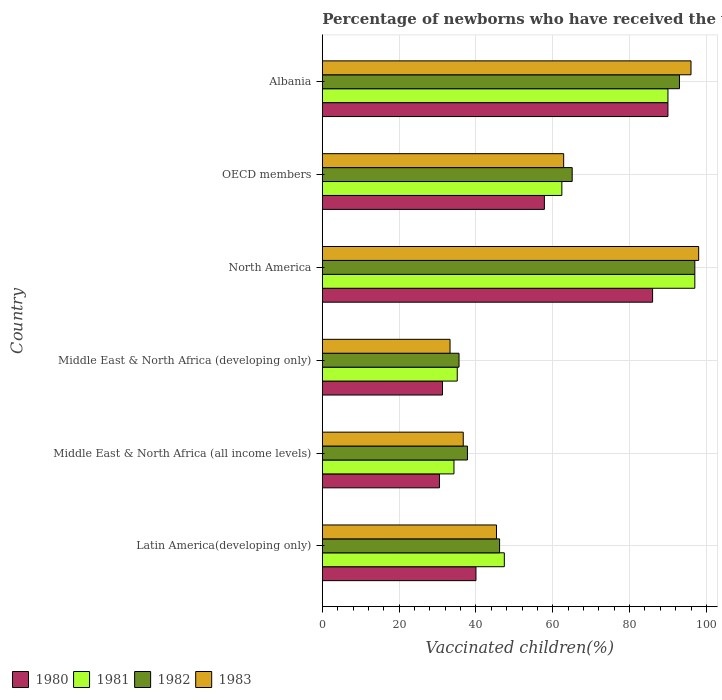How many different coloured bars are there?
Give a very brief answer. 4. Are the number of bars per tick equal to the number of legend labels?
Make the answer very short. Yes. How many bars are there on the 6th tick from the top?
Make the answer very short. 4. How many bars are there on the 4th tick from the bottom?
Your response must be concise. 4. What is the label of the 4th group of bars from the top?
Ensure brevity in your answer.  Middle East & North Africa (developing only). What is the percentage of vaccinated children in 1983 in Middle East & North Africa (all income levels)?
Your answer should be very brief. 36.7. Across all countries, what is the maximum percentage of vaccinated children in 1981?
Ensure brevity in your answer.  97. Across all countries, what is the minimum percentage of vaccinated children in 1981?
Ensure brevity in your answer.  34.28. In which country was the percentage of vaccinated children in 1982 minimum?
Ensure brevity in your answer.  Middle East & North Africa (developing only). What is the total percentage of vaccinated children in 1980 in the graph?
Your response must be concise. 335.62. What is the difference between the percentage of vaccinated children in 1980 in Middle East & North Africa (developing only) and that in North America?
Your response must be concise. -54.71. What is the difference between the percentage of vaccinated children in 1982 in OECD members and the percentage of vaccinated children in 1980 in North America?
Your response must be concise. -20.94. What is the average percentage of vaccinated children in 1982 per country?
Provide a short and direct response. 62.43. What is the difference between the percentage of vaccinated children in 1983 and percentage of vaccinated children in 1982 in Latin America(developing only)?
Provide a short and direct response. -0.8. In how many countries, is the percentage of vaccinated children in 1982 greater than 48 %?
Your answer should be very brief. 3. What is the ratio of the percentage of vaccinated children in 1983 in Latin America(developing only) to that in OECD members?
Your response must be concise. 0.72. What is the difference between the highest and the lowest percentage of vaccinated children in 1981?
Provide a succinct answer. 62.72. Is the sum of the percentage of vaccinated children in 1982 in Albania and OECD members greater than the maximum percentage of vaccinated children in 1980 across all countries?
Your answer should be very brief. Yes. Is it the case that in every country, the sum of the percentage of vaccinated children in 1980 and percentage of vaccinated children in 1981 is greater than the sum of percentage of vaccinated children in 1982 and percentage of vaccinated children in 1983?
Your answer should be very brief. No. What does the 2nd bar from the top in Latin America(developing only) represents?
Your answer should be compact. 1982. What does the 4th bar from the bottom in Middle East & North Africa (all income levels) represents?
Your answer should be very brief. 1983. Is it the case that in every country, the sum of the percentage of vaccinated children in 1982 and percentage of vaccinated children in 1981 is greater than the percentage of vaccinated children in 1983?
Give a very brief answer. Yes. What is the difference between two consecutive major ticks on the X-axis?
Offer a terse response. 20. Are the values on the major ticks of X-axis written in scientific E-notation?
Give a very brief answer. No. Does the graph contain any zero values?
Ensure brevity in your answer.  No. Does the graph contain grids?
Offer a very short reply. Yes. How many legend labels are there?
Offer a very short reply. 4. What is the title of the graph?
Give a very brief answer. Percentage of newborns who have received the vaccination for measles. What is the label or title of the X-axis?
Keep it short and to the point. Vaccinated children(%). What is the Vaccinated children(%) of 1980 in Latin America(developing only)?
Keep it short and to the point. 40.01. What is the Vaccinated children(%) in 1981 in Latin America(developing only)?
Your answer should be compact. 47.39. What is the Vaccinated children(%) in 1982 in Latin America(developing only)?
Provide a succinct answer. 46.16. What is the Vaccinated children(%) in 1983 in Latin America(developing only)?
Your answer should be very brief. 45.35. What is the Vaccinated children(%) in 1980 in Middle East & North Africa (all income levels)?
Provide a short and direct response. 30.5. What is the Vaccinated children(%) in 1981 in Middle East & North Africa (all income levels)?
Your answer should be very brief. 34.28. What is the Vaccinated children(%) in 1982 in Middle East & North Africa (all income levels)?
Your response must be concise. 37.79. What is the Vaccinated children(%) of 1983 in Middle East & North Africa (all income levels)?
Your response must be concise. 36.7. What is the Vaccinated children(%) in 1980 in Middle East & North Africa (developing only)?
Give a very brief answer. 31.29. What is the Vaccinated children(%) of 1981 in Middle East & North Africa (developing only)?
Offer a terse response. 35.13. What is the Vaccinated children(%) of 1982 in Middle East & North Africa (developing only)?
Give a very brief answer. 35.6. What is the Vaccinated children(%) in 1983 in Middle East & North Africa (developing only)?
Your answer should be compact. 33.26. What is the Vaccinated children(%) in 1980 in North America?
Offer a very short reply. 86. What is the Vaccinated children(%) in 1981 in North America?
Provide a succinct answer. 97. What is the Vaccinated children(%) in 1982 in North America?
Offer a very short reply. 97. What is the Vaccinated children(%) of 1983 in North America?
Your response must be concise. 98. What is the Vaccinated children(%) in 1980 in OECD members?
Keep it short and to the point. 57.82. What is the Vaccinated children(%) of 1981 in OECD members?
Ensure brevity in your answer.  62.37. What is the Vaccinated children(%) of 1982 in OECD members?
Offer a very short reply. 65.06. What is the Vaccinated children(%) in 1983 in OECD members?
Keep it short and to the point. 62.84. What is the Vaccinated children(%) of 1980 in Albania?
Make the answer very short. 90. What is the Vaccinated children(%) of 1981 in Albania?
Offer a very short reply. 90. What is the Vaccinated children(%) of 1982 in Albania?
Give a very brief answer. 93. What is the Vaccinated children(%) in 1983 in Albania?
Your answer should be compact. 96. Across all countries, what is the maximum Vaccinated children(%) in 1980?
Offer a very short reply. 90. Across all countries, what is the maximum Vaccinated children(%) in 1981?
Your response must be concise. 97. Across all countries, what is the maximum Vaccinated children(%) in 1982?
Offer a very short reply. 97. Across all countries, what is the maximum Vaccinated children(%) in 1983?
Your answer should be compact. 98. Across all countries, what is the minimum Vaccinated children(%) in 1980?
Your answer should be very brief. 30.5. Across all countries, what is the minimum Vaccinated children(%) in 1981?
Ensure brevity in your answer.  34.28. Across all countries, what is the minimum Vaccinated children(%) of 1982?
Provide a short and direct response. 35.6. Across all countries, what is the minimum Vaccinated children(%) in 1983?
Your answer should be compact. 33.26. What is the total Vaccinated children(%) in 1980 in the graph?
Your answer should be compact. 335.62. What is the total Vaccinated children(%) in 1981 in the graph?
Your answer should be very brief. 366.18. What is the total Vaccinated children(%) of 1982 in the graph?
Ensure brevity in your answer.  374.61. What is the total Vaccinated children(%) in 1983 in the graph?
Your answer should be compact. 372.15. What is the difference between the Vaccinated children(%) in 1980 in Latin America(developing only) and that in Middle East & North Africa (all income levels)?
Offer a very short reply. 9.51. What is the difference between the Vaccinated children(%) of 1981 in Latin America(developing only) and that in Middle East & North Africa (all income levels)?
Offer a very short reply. 13.11. What is the difference between the Vaccinated children(%) of 1982 in Latin America(developing only) and that in Middle East & North Africa (all income levels)?
Your answer should be very brief. 8.36. What is the difference between the Vaccinated children(%) in 1983 in Latin America(developing only) and that in Middle East & North Africa (all income levels)?
Your response must be concise. 8.66. What is the difference between the Vaccinated children(%) of 1980 in Latin America(developing only) and that in Middle East & North Africa (developing only)?
Ensure brevity in your answer.  8.72. What is the difference between the Vaccinated children(%) of 1981 in Latin America(developing only) and that in Middle East & North Africa (developing only)?
Ensure brevity in your answer.  12.26. What is the difference between the Vaccinated children(%) in 1982 in Latin America(developing only) and that in Middle East & North Africa (developing only)?
Your answer should be compact. 10.56. What is the difference between the Vaccinated children(%) in 1983 in Latin America(developing only) and that in Middle East & North Africa (developing only)?
Your answer should be compact. 12.1. What is the difference between the Vaccinated children(%) in 1980 in Latin America(developing only) and that in North America?
Make the answer very short. -45.99. What is the difference between the Vaccinated children(%) in 1981 in Latin America(developing only) and that in North America?
Provide a short and direct response. -49.61. What is the difference between the Vaccinated children(%) of 1982 in Latin America(developing only) and that in North America?
Provide a short and direct response. -50.84. What is the difference between the Vaccinated children(%) in 1983 in Latin America(developing only) and that in North America?
Provide a succinct answer. -52.65. What is the difference between the Vaccinated children(%) in 1980 in Latin America(developing only) and that in OECD members?
Your answer should be compact. -17.82. What is the difference between the Vaccinated children(%) in 1981 in Latin America(developing only) and that in OECD members?
Offer a terse response. -14.98. What is the difference between the Vaccinated children(%) in 1982 in Latin America(developing only) and that in OECD members?
Your answer should be very brief. -18.91. What is the difference between the Vaccinated children(%) of 1983 in Latin America(developing only) and that in OECD members?
Ensure brevity in your answer.  -17.49. What is the difference between the Vaccinated children(%) in 1980 in Latin America(developing only) and that in Albania?
Ensure brevity in your answer.  -49.99. What is the difference between the Vaccinated children(%) of 1981 in Latin America(developing only) and that in Albania?
Offer a very short reply. -42.61. What is the difference between the Vaccinated children(%) of 1982 in Latin America(developing only) and that in Albania?
Keep it short and to the point. -46.84. What is the difference between the Vaccinated children(%) in 1983 in Latin America(developing only) and that in Albania?
Your answer should be very brief. -50.65. What is the difference between the Vaccinated children(%) of 1980 in Middle East & North Africa (all income levels) and that in Middle East & North Africa (developing only)?
Your answer should be compact. -0.79. What is the difference between the Vaccinated children(%) in 1981 in Middle East & North Africa (all income levels) and that in Middle East & North Africa (developing only)?
Your answer should be compact. -0.86. What is the difference between the Vaccinated children(%) in 1982 in Middle East & North Africa (all income levels) and that in Middle East & North Africa (developing only)?
Offer a very short reply. 2.19. What is the difference between the Vaccinated children(%) in 1983 in Middle East & North Africa (all income levels) and that in Middle East & North Africa (developing only)?
Give a very brief answer. 3.44. What is the difference between the Vaccinated children(%) of 1980 in Middle East & North Africa (all income levels) and that in North America?
Give a very brief answer. -55.5. What is the difference between the Vaccinated children(%) of 1981 in Middle East & North Africa (all income levels) and that in North America?
Offer a very short reply. -62.72. What is the difference between the Vaccinated children(%) of 1982 in Middle East & North Africa (all income levels) and that in North America?
Provide a succinct answer. -59.21. What is the difference between the Vaccinated children(%) of 1983 in Middle East & North Africa (all income levels) and that in North America?
Make the answer very short. -61.3. What is the difference between the Vaccinated children(%) of 1980 in Middle East & North Africa (all income levels) and that in OECD members?
Your answer should be very brief. -27.32. What is the difference between the Vaccinated children(%) of 1981 in Middle East & North Africa (all income levels) and that in OECD members?
Provide a succinct answer. -28.1. What is the difference between the Vaccinated children(%) of 1982 in Middle East & North Africa (all income levels) and that in OECD members?
Your answer should be very brief. -27.27. What is the difference between the Vaccinated children(%) in 1983 in Middle East & North Africa (all income levels) and that in OECD members?
Provide a short and direct response. -26.15. What is the difference between the Vaccinated children(%) of 1980 in Middle East & North Africa (all income levels) and that in Albania?
Your answer should be compact. -59.5. What is the difference between the Vaccinated children(%) in 1981 in Middle East & North Africa (all income levels) and that in Albania?
Provide a succinct answer. -55.72. What is the difference between the Vaccinated children(%) of 1982 in Middle East & North Africa (all income levels) and that in Albania?
Your response must be concise. -55.21. What is the difference between the Vaccinated children(%) in 1983 in Middle East & North Africa (all income levels) and that in Albania?
Give a very brief answer. -59.3. What is the difference between the Vaccinated children(%) of 1980 in Middle East & North Africa (developing only) and that in North America?
Your answer should be very brief. -54.71. What is the difference between the Vaccinated children(%) of 1981 in Middle East & North Africa (developing only) and that in North America?
Your answer should be very brief. -61.87. What is the difference between the Vaccinated children(%) in 1982 in Middle East & North Africa (developing only) and that in North America?
Give a very brief answer. -61.4. What is the difference between the Vaccinated children(%) in 1983 in Middle East & North Africa (developing only) and that in North America?
Make the answer very short. -64.74. What is the difference between the Vaccinated children(%) in 1980 in Middle East & North Africa (developing only) and that in OECD members?
Ensure brevity in your answer.  -26.53. What is the difference between the Vaccinated children(%) in 1981 in Middle East & North Africa (developing only) and that in OECD members?
Your answer should be very brief. -27.24. What is the difference between the Vaccinated children(%) of 1982 in Middle East & North Africa (developing only) and that in OECD members?
Your answer should be very brief. -29.46. What is the difference between the Vaccinated children(%) in 1983 in Middle East & North Africa (developing only) and that in OECD members?
Give a very brief answer. -29.59. What is the difference between the Vaccinated children(%) in 1980 in Middle East & North Africa (developing only) and that in Albania?
Your answer should be very brief. -58.71. What is the difference between the Vaccinated children(%) of 1981 in Middle East & North Africa (developing only) and that in Albania?
Your answer should be very brief. -54.87. What is the difference between the Vaccinated children(%) in 1982 in Middle East & North Africa (developing only) and that in Albania?
Your response must be concise. -57.4. What is the difference between the Vaccinated children(%) of 1983 in Middle East & North Africa (developing only) and that in Albania?
Give a very brief answer. -62.74. What is the difference between the Vaccinated children(%) in 1980 in North America and that in OECD members?
Your response must be concise. 28.18. What is the difference between the Vaccinated children(%) in 1981 in North America and that in OECD members?
Offer a terse response. 34.63. What is the difference between the Vaccinated children(%) of 1982 in North America and that in OECD members?
Provide a succinct answer. 31.94. What is the difference between the Vaccinated children(%) of 1983 in North America and that in OECD members?
Give a very brief answer. 35.16. What is the difference between the Vaccinated children(%) in 1980 in North America and that in Albania?
Make the answer very short. -4. What is the difference between the Vaccinated children(%) in 1981 in North America and that in Albania?
Keep it short and to the point. 7. What is the difference between the Vaccinated children(%) in 1982 in North America and that in Albania?
Your response must be concise. 4. What is the difference between the Vaccinated children(%) in 1983 in North America and that in Albania?
Ensure brevity in your answer.  2. What is the difference between the Vaccinated children(%) in 1980 in OECD members and that in Albania?
Keep it short and to the point. -32.18. What is the difference between the Vaccinated children(%) of 1981 in OECD members and that in Albania?
Your answer should be very brief. -27.63. What is the difference between the Vaccinated children(%) of 1982 in OECD members and that in Albania?
Offer a very short reply. -27.94. What is the difference between the Vaccinated children(%) of 1983 in OECD members and that in Albania?
Your response must be concise. -33.16. What is the difference between the Vaccinated children(%) in 1980 in Latin America(developing only) and the Vaccinated children(%) in 1981 in Middle East & North Africa (all income levels)?
Provide a succinct answer. 5.73. What is the difference between the Vaccinated children(%) of 1980 in Latin America(developing only) and the Vaccinated children(%) of 1982 in Middle East & North Africa (all income levels)?
Your answer should be compact. 2.22. What is the difference between the Vaccinated children(%) of 1980 in Latin America(developing only) and the Vaccinated children(%) of 1983 in Middle East & North Africa (all income levels)?
Your response must be concise. 3.31. What is the difference between the Vaccinated children(%) of 1981 in Latin America(developing only) and the Vaccinated children(%) of 1982 in Middle East & North Africa (all income levels)?
Make the answer very short. 9.6. What is the difference between the Vaccinated children(%) of 1981 in Latin America(developing only) and the Vaccinated children(%) of 1983 in Middle East & North Africa (all income levels)?
Your answer should be very brief. 10.7. What is the difference between the Vaccinated children(%) of 1982 in Latin America(developing only) and the Vaccinated children(%) of 1983 in Middle East & North Africa (all income levels)?
Make the answer very short. 9.46. What is the difference between the Vaccinated children(%) of 1980 in Latin America(developing only) and the Vaccinated children(%) of 1981 in Middle East & North Africa (developing only)?
Give a very brief answer. 4.87. What is the difference between the Vaccinated children(%) of 1980 in Latin America(developing only) and the Vaccinated children(%) of 1982 in Middle East & North Africa (developing only)?
Give a very brief answer. 4.41. What is the difference between the Vaccinated children(%) of 1980 in Latin America(developing only) and the Vaccinated children(%) of 1983 in Middle East & North Africa (developing only)?
Offer a terse response. 6.75. What is the difference between the Vaccinated children(%) of 1981 in Latin America(developing only) and the Vaccinated children(%) of 1982 in Middle East & North Africa (developing only)?
Ensure brevity in your answer.  11.8. What is the difference between the Vaccinated children(%) of 1981 in Latin America(developing only) and the Vaccinated children(%) of 1983 in Middle East & North Africa (developing only)?
Make the answer very short. 14.14. What is the difference between the Vaccinated children(%) of 1982 in Latin America(developing only) and the Vaccinated children(%) of 1983 in Middle East & North Africa (developing only)?
Provide a short and direct response. 12.9. What is the difference between the Vaccinated children(%) of 1980 in Latin America(developing only) and the Vaccinated children(%) of 1981 in North America?
Make the answer very short. -56.99. What is the difference between the Vaccinated children(%) of 1980 in Latin America(developing only) and the Vaccinated children(%) of 1982 in North America?
Offer a terse response. -56.99. What is the difference between the Vaccinated children(%) of 1980 in Latin America(developing only) and the Vaccinated children(%) of 1983 in North America?
Keep it short and to the point. -57.99. What is the difference between the Vaccinated children(%) in 1981 in Latin America(developing only) and the Vaccinated children(%) in 1982 in North America?
Ensure brevity in your answer.  -49.61. What is the difference between the Vaccinated children(%) of 1981 in Latin America(developing only) and the Vaccinated children(%) of 1983 in North America?
Offer a terse response. -50.61. What is the difference between the Vaccinated children(%) in 1982 in Latin America(developing only) and the Vaccinated children(%) in 1983 in North America?
Your answer should be compact. -51.84. What is the difference between the Vaccinated children(%) in 1980 in Latin America(developing only) and the Vaccinated children(%) in 1981 in OECD members?
Provide a succinct answer. -22.37. What is the difference between the Vaccinated children(%) of 1980 in Latin America(developing only) and the Vaccinated children(%) of 1982 in OECD members?
Your response must be concise. -25.05. What is the difference between the Vaccinated children(%) in 1980 in Latin America(developing only) and the Vaccinated children(%) in 1983 in OECD members?
Give a very brief answer. -22.84. What is the difference between the Vaccinated children(%) of 1981 in Latin America(developing only) and the Vaccinated children(%) of 1982 in OECD members?
Offer a terse response. -17.67. What is the difference between the Vaccinated children(%) in 1981 in Latin America(developing only) and the Vaccinated children(%) in 1983 in OECD members?
Make the answer very short. -15.45. What is the difference between the Vaccinated children(%) in 1982 in Latin America(developing only) and the Vaccinated children(%) in 1983 in OECD members?
Your response must be concise. -16.69. What is the difference between the Vaccinated children(%) in 1980 in Latin America(developing only) and the Vaccinated children(%) in 1981 in Albania?
Make the answer very short. -49.99. What is the difference between the Vaccinated children(%) of 1980 in Latin America(developing only) and the Vaccinated children(%) of 1982 in Albania?
Your response must be concise. -52.99. What is the difference between the Vaccinated children(%) of 1980 in Latin America(developing only) and the Vaccinated children(%) of 1983 in Albania?
Your response must be concise. -55.99. What is the difference between the Vaccinated children(%) of 1981 in Latin America(developing only) and the Vaccinated children(%) of 1982 in Albania?
Your response must be concise. -45.61. What is the difference between the Vaccinated children(%) in 1981 in Latin America(developing only) and the Vaccinated children(%) in 1983 in Albania?
Your answer should be very brief. -48.61. What is the difference between the Vaccinated children(%) in 1982 in Latin America(developing only) and the Vaccinated children(%) in 1983 in Albania?
Offer a very short reply. -49.84. What is the difference between the Vaccinated children(%) in 1980 in Middle East & North Africa (all income levels) and the Vaccinated children(%) in 1981 in Middle East & North Africa (developing only)?
Your answer should be compact. -4.63. What is the difference between the Vaccinated children(%) in 1980 in Middle East & North Africa (all income levels) and the Vaccinated children(%) in 1982 in Middle East & North Africa (developing only)?
Give a very brief answer. -5.1. What is the difference between the Vaccinated children(%) of 1980 in Middle East & North Africa (all income levels) and the Vaccinated children(%) of 1983 in Middle East & North Africa (developing only)?
Your answer should be compact. -2.75. What is the difference between the Vaccinated children(%) in 1981 in Middle East & North Africa (all income levels) and the Vaccinated children(%) in 1982 in Middle East & North Africa (developing only)?
Offer a terse response. -1.32. What is the difference between the Vaccinated children(%) in 1981 in Middle East & North Africa (all income levels) and the Vaccinated children(%) in 1983 in Middle East & North Africa (developing only)?
Offer a very short reply. 1.02. What is the difference between the Vaccinated children(%) in 1982 in Middle East & North Africa (all income levels) and the Vaccinated children(%) in 1983 in Middle East & North Africa (developing only)?
Ensure brevity in your answer.  4.54. What is the difference between the Vaccinated children(%) of 1980 in Middle East & North Africa (all income levels) and the Vaccinated children(%) of 1981 in North America?
Keep it short and to the point. -66.5. What is the difference between the Vaccinated children(%) of 1980 in Middle East & North Africa (all income levels) and the Vaccinated children(%) of 1982 in North America?
Ensure brevity in your answer.  -66.5. What is the difference between the Vaccinated children(%) in 1980 in Middle East & North Africa (all income levels) and the Vaccinated children(%) in 1983 in North America?
Your response must be concise. -67.5. What is the difference between the Vaccinated children(%) of 1981 in Middle East & North Africa (all income levels) and the Vaccinated children(%) of 1982 in North America?
Give a very brief answer. -62.72. What is the difference between the Vaccinated children(%) in 1981 in Middle East & North Africa (all income levels) and the Vaccinated children(%) in 1983 in North America?
Ensure brevity in your answer.  -63.72. What is the difference between the Vaccinated children(%) in 1982 in Middle East & North Africa (all income levels) and the Vaccinated children(%) in 1983 in North America?
Give a very brief answer. -60.21. What is the difference between the Vaccinated children(%) in 1980 in Middle East & North Africa (all income levels) and the Vaccinated children(%) in 1981 in OECD members?
Provide a short and direct response. -31.87. What is the difference between the Vaccinated children(%) in 1980 in Middle East & North Africa (all income levels) and the Vaccinated children(%) in 1982 in OECD members?
Make the answer very short. -34.56. What is the difference between the Vaccinated children(%) of 1980 in Middle East & North Africa (all income levels) and the Vaccinated children(%) of 1983 in OECD members?
Your answer should be very brief. -32.34. What is the difference between the Vaccinated children(%) in 1981 in Middle East & North Africa (all income levels) and the Vaccinated children(%) in 1982 in OECD members?
Your answer should be compact. -30.78. What is the difference between the Vaccinated children(%) of 1981 in Middle East & North Africa (all income levels) and the Vaccinated children(%) of 1983 in OECD members?
Offer a terse response. -28.57. What is the difference between the Vaccinated children(%) in 1982 in Middle East & North Africa (all income levels) and the Vaccinated children(%) in 1983 in OECD members?
Offer a terse response. -25.05. What is the difference between the Vaccinated children(%) of 1980 in Middle East & North Africa (all income levels) and the Vaccinated children(%) of 1981 in Albania?
Offer a terse response. -59.5. What is the difference between the Vaccinated children(%) in 1980 in Middle East & North Africa (all income levels) and the Vaccinated children(%) in 1982 in Albania?
Keep it short and to the point. -62.5. What is the difference between the Vaccinated children(%) in 1980 in Middle East & North Africa (all income levels) and the Vaccinated children(%) in 1983 in Albania?
Your response must be concise. -65.5. What is the difference between the Vaccinated children(%) of 1981 in Middle East & North Africa (all income levels) and the Vaccinated children(%) of 1982 in Albania?
Provide a short and direct response. -58.72. What is the difference between the Vaccinated children(%) of 1981 in Middle East & North Africa (all income levels) and the Vaccinated children(%) of 1983 in Albania?
Give a very brief answer. -61.72. What is the difference between the Vaccinated children(%) in 1982 in Middle East & North Africa (all income levels) and the Vaccinated children(%) in 1983 in Albania?
Ensure brevity in your answer.  -58.21. What is the difference between the Vaccinated children(%) in 1980 in Middle East & North Africa (developing only) and the Vaccinated children(%) in 1981 in North America?
Keep it short and to the point. -65.71. What is the difference between the Vaccinated children(%) in 1980 in Middle East & North Africa (developing only) and the Vaccinated children(%) in 1982 in North America?
Give a very brief answer. -65.71. What is the difference between the Vaccinated children(%) of 1980 in Middle East & North Africa (developing only) and the Vaccinated children(%) of 1983 in North America?
Offer a terse response. -66.71. What is the difference between the Vaccinated children(%) of 1981 in Middle East & North Africa (developing only) and the Vaccinated children(%) of 1982 in North America?
Give a very brief answer. -61.87. What is the difference between the Vaccinated children(%) of 1981 in Middle East & North Africa (developing only) and the Vaccinated children(%) of 1983 in North America?
Your answer should be compact. -62.87. What is the difference between the Vaccinated children(%) of 1982 in Middle East & North Africa (developing only) and the Vaccinated children(%) of 1983 in North America?
Your answer should be compact. -62.4. What is the difference between the Vaccinated children(%) of 1980 in Middle East & North Africa (developing only) and the Vaccinated children(%) of 1981 in OECD members?
Keep it short and to the point. -31.08. What is the difference between the Vaccinated children(%) of 1980 in Middle East & North Africa (developing only) and the Vaccinated children(%) of 1982 in OECD members?
Your response must be concise. -33.77. What is the difference between the Vaccinated children(%) in 1980 in Middle East & North Africa (developing only) and the Vaccinated children(%) in 1983 in OECD members?
Offer a very short reply. -31.55. What is the difference between the Vaccinated children(%) of 1981 in Middle East & North Africa (developing only) and the Vaccinated children(%) of 1982 in OECD members?
Your answer should be very brief. -29.93. What is the difference between the Vaccinated children(%) in 1981 in Middle East & North Africa (developing only) and the Vaccinated children(%) in 1983 in OECD members?
Give a very brief answer. -27.71. What is the difference between the Vaccinated children(%) in 1982 in Middle East & North Africa (developing only) and the Vaccinated children(%) in 1983 in OECD members?
Your answer should be very brief. -27.25. What is the difference between the Vaccinated children(%) in 1980 in Middle East & North Africa (developing only) and the Vaccinated children(%) in 1981 in Albania?
Ensure brevity in your answer.  -58.71. What is the difference between the Vaccinated children(%) of 1980 in Middle East & North Africa (developing only) and the Vaccinated children(%) of 1982 in Albania?
Make the answer very short. -61.71. What is the difference between the Vaccinated children(%) in 1980 in Middle East & North Africa (developing only) and the Vaccinated children(%) in 1983 in Albania?
Your response must be concise. -64.71. What is the difference between the Vaccinated children(%) in 1981 in Middle East & North Africa (developing only) and the Vaccinated children(%) in 1982 in Albania?
Give a very brief answer. -57.87. What is the difference between the Vaccinated children(%) in 1981 in Middle East & North Africa (developing only) and the Vaccinated children(%) in 1983 in Albania?
Offer a very short reply. -60.87. What is the difference between the Vaccinated children(%) in 1982 in Middle East & North Africa (developing only) and the Vaccinated children(%) in 1983 in Albania?
Offer a terse response. -60.4. What is the difference between the Vaccinated children(%) in 1980 in North America and the Vaccinated children(%) in 1981 in OECD members?
Provide a succinct answer. 23.63. What is the difference between the Vaccinated children(%) of 1980 in North America and the Vaccinated children(%) of 1982 in OECD members?
Your answer should be compact. 20.94. What is the difference between the Vaccinated children(%) in 1980 in North America and the Vaccinated children(%) in 1983 in OECD members?
Offer a very short reply. 23.16. What is the difference between the Vaccinated children(%) in 1981 in North America and the Vaccinated children(%) in 1982 in OECD members?
Provide a short and direct response. 31.94. What is the difference between the Vaccinated children(%) of 1981 in North America and the Vaccinated children(%) of 1983 in OECD members?
Give a very brief answer. 34.16. What is the difference between the Vaccinated children(%) of 1982 in North America and the Vaccinated children(%) of 1983 in OECD members?
Your answer should be very brief. 34.16. What is the difference between the Vaccinated children(%) in 1980 in North America and the Vaccinated children(%) in 1981 in Albania?
Offer a very short reply. -4. What is the difference between the Vaccinated children(%) of 1980 in North America and the Vaccinated children(%) of 1982 in Albania?
Provide a succinct answer. -7. What is the difference between the Vaccinated children(%) in 1980 in North America and the Vaccinated children(%) in 1983 in Albania?
Keep it short and to the point. -10. What is the difference between the Vaccinated children(%) of 1981 in North America and the Vaccinated children(%) of 1982 in Albania?
Provide a short and direct response. 4. What is the difference between the Vaccinated children(%) in 1980 in OECD members and the Vaccinated children(%) in 1981 in Albania?
Provide a succinct answer. -32.18. What is the difference between the Vaccinated children(%) in 1980 in OECD members and the Vaccinated children(%) in 1982 in Albania?
Provide a succinct answer. -35.18. What is the difference between the Vaccinated children(%) in 1980 in OECD members and the Vaccinated children(%) in 1983 in Albania?
Provide a short and direct response. -38.18. What is the difference between the Vaccinated children(%) in 1981 in OECD members and the Vaccinated children(%) in 1982 in Albania?
Offer a very short reply. -30.63. What is the difference between the Vaccinated children(%) of 1981 in OECD members and the Vaccinated children(%) of 1983 in Albania?
Offer a terse response. -33.63. What is the difference between the Vaccinated children(%) of 1982 in OECD members and the Vaccinated children(%) of 1983 in Albania?
Your response must be concise. -30.94. What is the average Vaccinated children(%) in 1980 per country?
Your answer should be compact. 55.94. What is the average Vaccinated children(%) of 1981 per country?
Your answer should be compact. 61.03. What is the average Vaccinated children(%) of 1982 per country?
Make the answer very short. 62.43. What is the average Vaccinated children(%) in 1983 per country?
Offer a very short reply. 62.02. What is the difference between the Vaccinated children(%) of 1980 and Vaccinated children(%) of 1981 in Latin America(developing only)?
Your answer should be compact. -7.39. What is the difference between the Vaccinated children(%) in 1980 and Vaccinated children(%) in 1982 in Latin America(developing only)?
Your response must be concise. -6.15. What is the difference between the Vaccinated children(%) in 1980 and Vaccinated children(%) in 1983 in Latin America(developing only)?
Make the answer very short. -5.35. What is the difference between the Vaccinated children(%) of 1981 and Vaccinated children(%) of 1982 in Latin America(developing only)?
Ensure brevity in your answer.  1.24. What is the difference between the Vaccinated children(%) of 1981 and Vaccinated children(%) of 1983 in Latin America(developing only)?
Your response must be concise. 2.04. What is the difference between the Vaccinated children(%) of 1982 and Vaccinated children(%) of 1983 in Latin America(developing only)?
Provide a short and direct response. 0.8. What is the difference between the Vaccinated children(%) of 1980 and Vaccinated children(%) of 1981 in Middle East & North Africa (all income levels)?
Your answer should be very brief. -3.78. What is the difference between the Vaccinated children(%) of 1980 and Vaccinated children(%) of 1982 in Middle East & North Africa (all income levels)?
Provide a succinct answer. -7.29. What is the difference between the Vaccinated children(%) of 1980 and Vaccinated children(%) of 1983 in Middle East & North Africa (all income levels)?
Provide a short and direct response. -6.19. What is the difference between the Vaccinated children(%) of 1981 and Vaccinated children(%) of 1982 in Middle East & North Africa (all income levels)?
Your answer should be very brief. -3.51. What is the difference between the Vaccinated children(%) in 1981 and Vaccinated children(%) in 1983 in Middle East & North Africa (all income levels)?
Provide a short and direct response. -2.42. What is the difference between the Vaccinated children(%) of 1982 and Vaccinated children(%) of 1983 in Middle East & North Africa (all income levels)?
Your response must be concise. 1.1. What is the difference between the Vaccinated children(%) of 1980 and Vaccinated children(%) of 1981 in Middle East & North Africa (developing only)?
Offer a very short reply. -3.84. What is the difference between the Vaccinated children(%) in 1980 and Vaccinated children(%) in 1982 in Middle East & North Africa (developing only)?
Your response must be concise. -4.31. What is the difference between the Vaccinated children(%) in 1980 and Vaccinated children(%) in 1983 in Middle East & North Africa (developing only)?
Provide a succinct answer. -1.97. What is the difference between the Vaccinated children(%) of 1981 and Vaccinated children(%) of 1982 in Middle East & North Africa (developing only)?
Ensure brevity in your answer.  -0.46. What is the difference between the Vaccinated children(%) in 1981 and Vaccinated children(%) in 1983 in Middle East & North Africa (developing only)?
Give a very brief answer. 1.88. What is the difference between the Vaccinated children(%) in 1982 and Vaccinated children(%) in 1983 in Middle East & North Africa (developing only)?
Make the answer very short. 2.34. What is the difference between the Vaccinated children(%) in 1980 and Vaccinated children(%) in 1981 in North America?
Your answer should be very brief. -11. What is the difference between the Vaccinated children(%) in 1981 and Vaccinated children(%) in 1982 in North America?
Keep it short and to the point. 0. What is the difference between the Vaccinated children(%) in 1980 and Vaccinated children(%) in 1981 in OECD members?
Offer a very short reply. -4.55. What is the difference between the Vaccinated children(%) in 1980 and Vaccinated children(%) in 1982 in OECD members?
Make the answer very short. -7.24. What is the difference between the Vaccinated children(%) of 1980 and Vaccinated children(%) of 1983 in OECD members?
Make the answer very short. -5.02. What is the difference between the Vaccinated children(%) in 1981 and Vaccinated children(%) in 1982 in OECD members?
Your answer should be very brief. -2.69. What is the difference between the Vaccinated children(%) in 1981 and Vaccinated children(%) in 1983 in OECD members?
Ensure brevity in your answer.  -0.47. What is the difference between the Vaccinated children(%) in 1982 and Vaccinated children(%) in 1983 in OECD members?
Keep it short and to the point. 2.22. What is the difference between the Vaccinated children(%) in 1981 and Vaccinated children(%) in 1982 in Albania?
Your answer should be very brief. -3. What is the difference between the Vaccinated children(%) of 1982 and Vaccinated children(%) of 1983 in Albania?
Offer a terse response. -3. What is the ratio of the Vaccinated children(%) of 1980 in Latin America(developing only) to that in Middle East & North Africa (all income levels)?
Keep it short and to the point. 1.31. What is the ratio of the Vaccinated children(%) in 1981 in Latin America(developing only) to that in Middle East & North Africa (all income levels)?
Provide a succinct answer. 1.38. What is the ratio of the Vaccinated children(%) of 1982 in Latin America(developing only) to that in Middle East & North Africa (all income levels)?
Ensure brevity in your answer.  1.22. What is the ratio of the Vaccinated children(%) of 1983 in Latin America(developing only) to that in Middle East & North Africa (all income levels)?
Provide a succinct answer. 1.24. What is the ratio of the Vaccinated children(%) of 1980 in Latin America(developing only) to that in Middle East & North Africa (developing only)?
Offer a terse response. 1.28. What is the ratio of the Vaccinated children(%) of 1981 in Latin America(developing only) to that in Middle East & North Africa (developing only)?
Provide a succinct answer. 1.35. What is the ratio of the Vaccinated children(%) of 1982 in Latin America(developing only) to that in Middle East & North Africa (developing only)?
Offer a very short reply. 1.3. What is the ratio of the Vaccinated children(%) of 1983 in Latin America(developing only) to that in Middle East & North Africa (developing only)?
Offer a very short reply. 1.36. What is the ratio of the Vaccinated children(%) of 1980 in Latin America(developing only) to that in North America?
Offer a very short reply. 0.47. What is the ratio of the Vaccinated children(%) in 1981 in Latin America(developing only) to that in North America?
Offer a very short reply. 0.49. What is the ratio of the Vaccinated children(%) of 1982 in Latin America(developing only) to that in North America?
Provide a short and direct response. 0.48. What is the ratio of the Vaccinated children(%) in 1983 in Latin America(developing only) to that in North America?
Provide a short and direct response. 0.46. What is the ratio of the Vaccinated children(%) in 1980 in Latin America(developing only) to that in OECD members?
Make the answer very short. 0.69. What is the ratio of the Vaccinated children(%) of 1981 in Latin America(developing only) to that in OECD members?
Your answer should be compact. 0.76. What is the ratio of the Vaccinated children(%) of 1982 in Latin America(developing only) to that in OECD members?
Offer a very short reply. 0.71. What is the ratio of the Vaccinated children(%) in 1983 in Latin America(developing only) to that in OECD members?
Your response must be concise. 0.72. What is the ratio of the Vaccinated children(%) in 1980 in Latin America(developing only) to that in Albania?
Ensure brevity in your answer.  0.44. What is the ratio of the Vaccinated children(%) in 1981 in Latin America(developing only) to that in Albania?
Make the answer very short. 0.53. What is the ratio of the Vaccinated children(%) in 1982 in Latin America(developing only) to that in Albania?
Keep it short and to the point. 0.5. What is the ratio of the Vaccinated children(%) of 1983 in Latin America(developing only) to that in Albania?
Ensure brevity in your answer.  0.47. What is the ratio of the Vaccinated children(%) of 1980 in Middle East & North Africa (all income levels) to that in Middle East & North Africa (developing only)?
Make the answer very short. 0.97. What is the ratio of the Vaccinated children(%) in 1981 in Middle East & North Africa (all income levels) to that in Middle East & North Africa (developing only)?
Your answer should be very brief. 0.98. What is the ratio of the Vaccinated children(%) in 1982 in Middle East & North Africa (all income levels) to that in Middle East & North Africa (developing only)?
Keep it short and to the point. 1.06. What is the ratio of the Vaccinated children(%) in 1983 in Middle East & North Africa (all income levels) to that in Middle East & North Africa (developing only)?
Your answer should be compact. 1.1. What is the ratio of the Vaccinated children(%) in 1980 in Middle East & North Africa (all income levels) to that in North America?
Keep it short and to the point. 0.35. What is the ratio of the Vaccinated children(%) in 1981 in Middle East & North Africa (all income levels) to that in North America?
Give a very brief answer. 0.35. What is the ratio of the Vaccinated children(%) of 1982 in Middle East & North Africa (all income levels) to that in North America?
Ensure brevity in your answer.  0.39. What is the ratio of the Vaccinated children(%) in 1983 in Middle East & North Africa (all income levels) to that in North America?
Make the answer very short. 0.37. What is the ratio of the Vaccinated children(%) of 1980 in Middle East & North Africa (all income levels) to that in OECD members?
Keep it short and to the point. 0.53. What is the ratio of the Vaccinated children(%) of 1981 in Middle East & North Africa (all income levels) to that in OECD members?
Your answer should be compact. 0.55. What is the ratio of the Vaccinated children(%) in 1982 in Middle East & North Africa (all income levels) to that in OECD members?
Offer a very short reply. 0.58. What is the ratio of the Vaccinated children(%) in 1983 in Middle East & North Africa (all income levels) to that in OECD members?
Give a very brief answer. 0.58. What is the ratio of the Vaccinated children(%) in 1980 in Middle East & North Africa (all income levels) to that in Albania?
Keep it short and to the point. 0.34. What is the ratio of the Vaccinated children(%) in 1981 in Middle East & North Africa (all income levels) to that in Albania?
Your answer should be very brief. 0.38. What is the ratio of the Vaccinated children(%) in 1982 in Middle East & North Africa (all income levels) to that in Albania?
Keep it short and to the point. 0.41. What is the ratio of the Vaccinated children(%) in 1983 in Middle East & North Africa (all income levels) to that in Albania?
Offer a very short reply. 0.38. What is the ratio of the Vaccinated children(%) of 1980 in Middle East & North Africa (developing only) to that in North America?
Ensure brevity in your answer.  0.36. What is the ratio of the Vaccinated children(%) of 1981 in Middle East & North Africa (developing only) to that in North America?
Provide a succinct answer. 0.36. What is the ratio of the Vaccinated children(%) in 1982 in Middle East & North Africa (developing only) to that in North America?
Provide a short and direct response. 0.37. What is the ratio of the Vaccinated children(%) of 1983 in Middle East & North Africa (developing only) to that in North America?
Ensure brevity in your answer.  0.34. What is the ratio of the Vaccinated children(%) in 1980 in Middle East & North Africa (developing only) to that in OECD members?
Keep it short and to the point. 0.54. What is the ratio of the Vaccinated children(%) in 1981 in Middle East & North Africa (developing only) to that in OECD members?
Ensure brevity in your answer.  0.56. What is the ratio of the Vaccinated children(%) in 1982 in Middle East & North Africa (developing only) to that in OECD members?
Your answer should be compact. 0.55. What is the ratio of the Vaccinated children(%) of 1983 in Middle East & North Africa (developing only) to that in OECD members?
Keep it short and to the point. 0.53. What is the ratio of the Vaccinated children(%) in 1980 in Middle East & North Africa (developing only) to that in Albania?
Ensure brevity in your answer.  0.35. What is the ratio of the Vaccinated children(%) of 1981 in Middle East & North Africa (developing only) to that in Albania?
Offer a very short reply. 0.39. What is the ratio of the Vaccinated children(%) in 1982 in Middle East & North Africa (developing only) to that in Albania?
Provide a short and direct response. 0.38. What is the ratio of the Vaccinated children(%) of 1983 in Middle East & North Africa (developing only) to that in Albania?
Ensure brevity in your answer.  0.35. What is the ratio of the Vaccinated children(%) of 1980 in North America to that in OECD members?
Offer a terse response. 1.49. What is the ratio of the Vaccinated children(%) of 1981 in North America to that in OECD members?
Provide a succinct answer. 1.56. What is the ratio of the Vaccinated children(%) of 1982 in North America to that in OECD members?
Provide a succinct answer. 1.49. What is the ratio of the Vaccinated children(%) of 1983 in North America to that in OECD members?
Provide a succinct answer. 1.56. What is the ratio of the Vaccinated children(%) in 1980 in North America to that in Albania?
Offer a very short reply. 0.96. What is the ratio of the Vaccinated children(%) of 1981 in North America to that in Albania?
Make the answer very short. 1.08. What is the ratio of the Vaccinated children(%) of 1982 in North America to that in Albania?
Your response must be concise. 1.04. What is the ratio of the Vaccinated children(%) of 1983 in North America to that in Albania?
Keep it short and to the point. 1.02. What is the ratio of the Vaccinated children(%) of 1980 in OECD members to that in Albania?
Your answer should be compact. 0.64. What is the ratio of the Vaccinated children(%) in 1981 in OECD members to that in Albania?
Your response must be concise. 0.69. What is the ratio of the Vaccinated children(%) of 1982 in OECD members to that in Albania?
Give a very brief answer. 0.7. What is the ratio of the Vaccinated children(%) of 1983 in OECD members to that in Albania?
Make the answer very short. 0.65. What is the difference between the highest and the second highest Vaccinated children(%) of 1980?
Your response must be concise. 4. What is the difference between the highest and the second highest Vaccinated children(%) in 1982?
Your answer should be compact. 4. What is the difference between the highest and the second highest Vaccinated children(%) in 1983?
Offer a terse response. 2. What is the difference between the highest and the lowest Vaccinated children(%) of 1980?
Ensure brevity in your answer.  59.5. What is the difference between the highest and the lowest Vaccinated children(%) of 1981?
Make the answer very short. 62.72. What is the difference between the highest and the lowest Vaccinated children(%) of 1982?
Your response must be concise. 61.4. What is the difference between the highest and the lowest Vaccinated children(%) in 1983?
Offer a terse response. 64.74. 